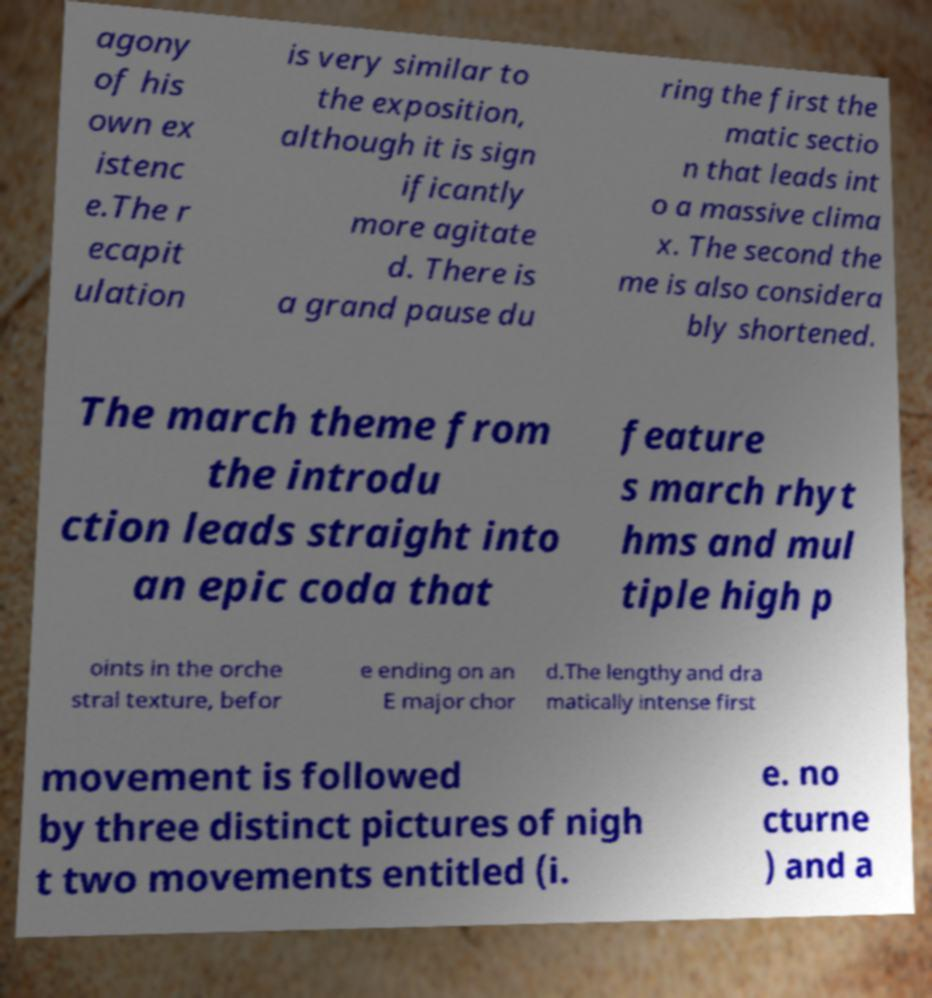What messages or text are displayed in this image? I need them in a readable, typed format. agony of his own ex istenc e.The r ecapit ulation is very similar to the exposition, although it is sign ificantly more agitate d. There is a grand pause du ring the first the matic sectio n that leads int o a massive clima x. The second the me is also considera bly shortened. The march theme from the introdu ction leads straight into an epic coda that feature s march rhyt hms and mul tiple high p oints in the orche stral texture, befor e ending on an E major chor d.The lengthy and dra matically intense first movement is followed by three distinct pictures of nigh t two movements entitled (i. e. no cturne ) and a 